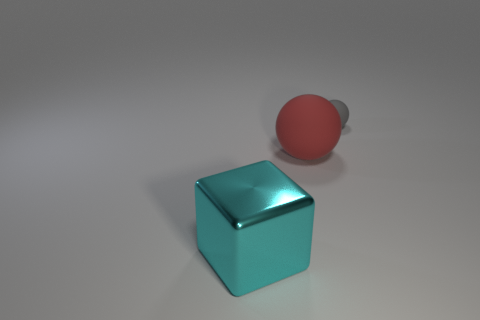Is the number of tiny gray spheres less than the number of large things?
Your answer should be very brief. Yes. What shape is the rubber object to the left of the object that is right of the red thing?
Give a very brief answer. Sphere. Are there any other things that are the same size as the gray ball?
Offer a terse response. No. There is a large thing behind the large object left of the ball that is in front of the tiny thing; what shape is it?
Your response must be concise. Sphere. What number of objects are rubber things behind the red matte object or things to the right of the large cyan metal object?
Give a very brief answer. 2. There is a cyan cube; is it the same size as the ball that is in front of the small gray object?
Keep it short and to the point. Yes. Is the big thing behind the large cyan thing made of the same material as the big object that is in front of the big red matte thing?
Ensure brevity in your answer.  No. Are there the same number of large red matte things behind the large cyan object and cyan things that are to the right of the large matte object?
Your answer should be compact. No. How many other objects are the same color as the large rubber object?
Keep it short and to the point. 0. What number of metallic objects are either tiny gray cylinders or cyan things?
Make the answer very short. 1. 